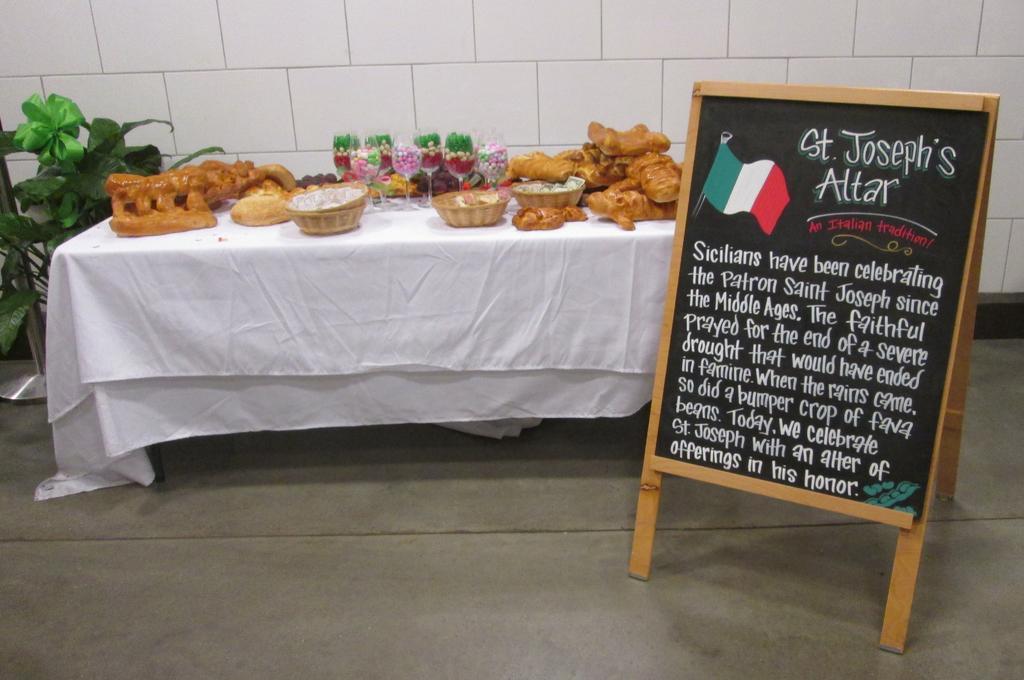How would you summarize this image in a sentence or two? On the right side of the image we can see a board and we can find some text on it, beside the board we can see baskets, glasses and other things on the table, on the left side of the image we can find a metal rod and plants. 